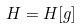Convert formula to latex. <formula><loc_0><loc_0><loc_500><loc_500>H = H [ g ]</formula> 